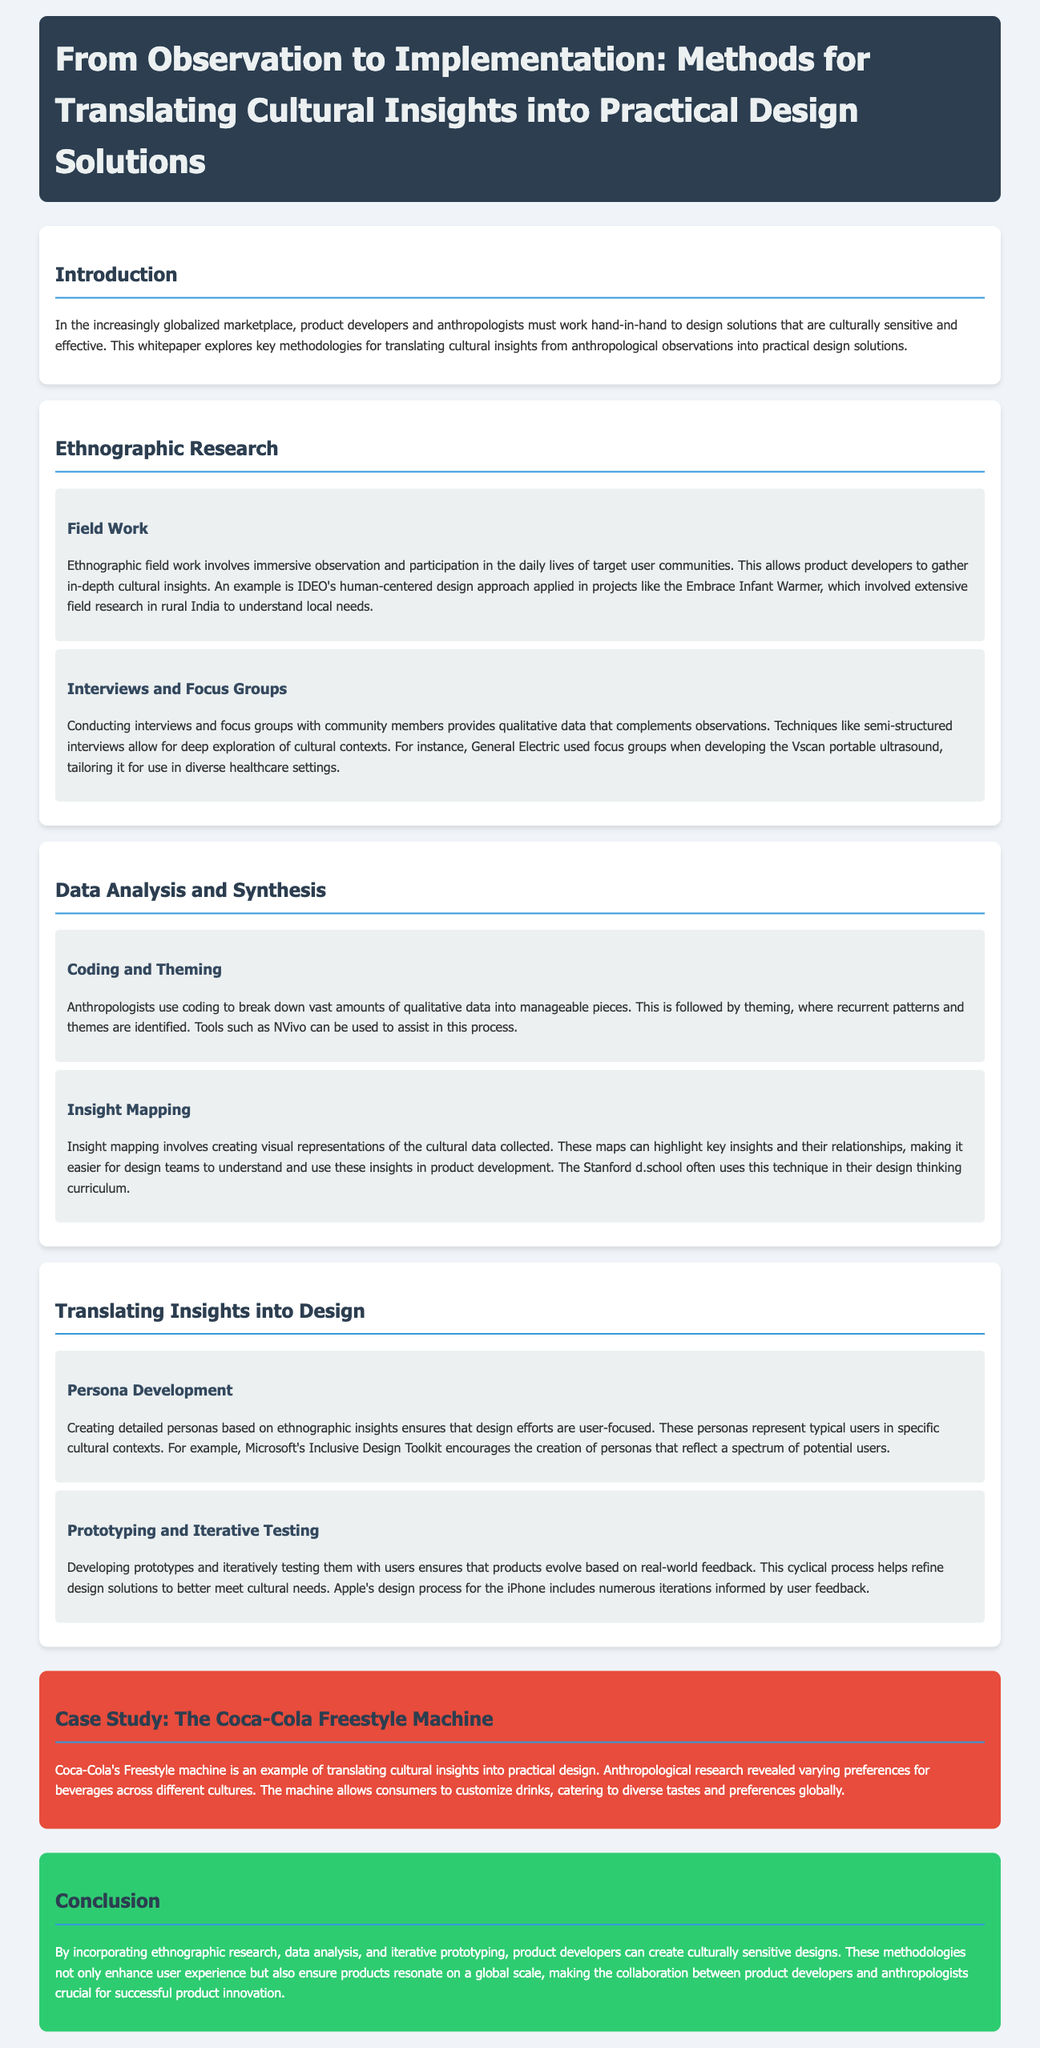What is the title of the whitepaper? The title is mentioned in the header of the document.
Answer: From Observation to Implementation: Methods for Translating Cultural Insights into Practical Design Solutions What example is given for ethnographic field work? The whitepaper provides a specific project to illustrate ethnographic field work.
Answer: IDEO's human-centered design approach What technique is used for qualitative data collection in interviews? The document describes specific techniques used to gather deeper insights.
Answer: Semi-structured interviews What tool is mentioned for coding qualitative data? The document discusses tools used in the process of analyzing data.
Answer: NVivo How does the Freestyle machine cater to cultural preferences? The document explains how Coca-Cola's design considered cultural insights.
Answer: Customization of drinks What process is emphasized for design evolution? The whitepaper discusses best practices in iterative development.
Answer: Prototyping and iterative testing What is a crucial collaboration mentioned in the conclusion? The conclusion highlights important teamwork in product development.
Answer: Product developers and anthropologists Which aspect of design does the Inclusive Design Toolkit address? The document mentions methods that focus on user representation in design.
Answer: Persona development 